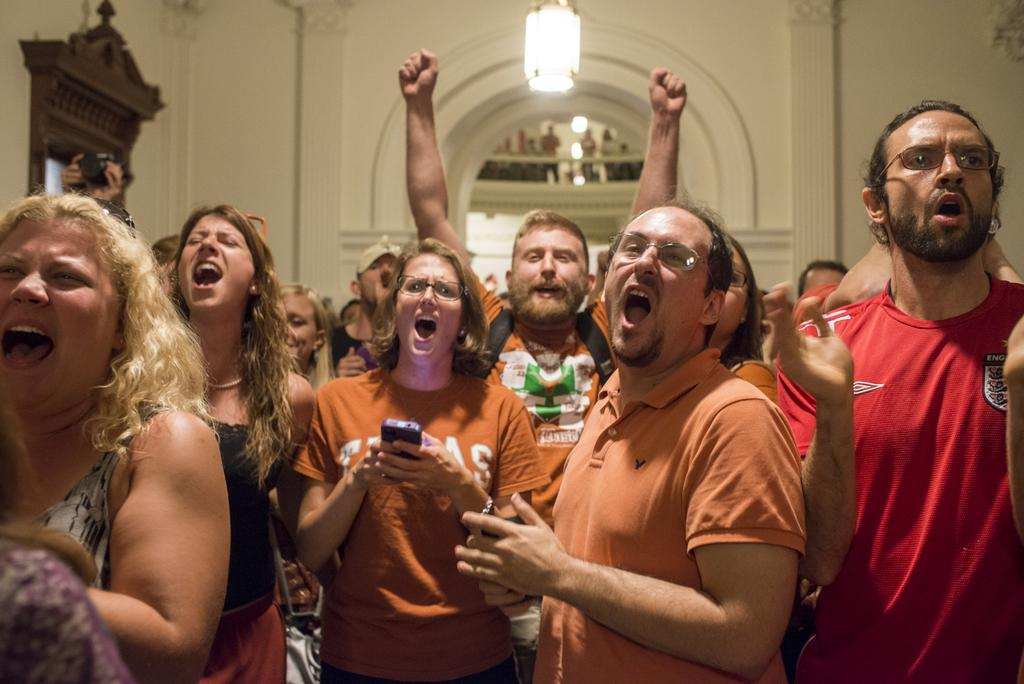What are the people in the image doing? The people in the image are standing and shouting. What can be seen in the background of the image? There is a wall in the background of the image. How can people enter or exit the area behind the wall? There is an entrance for the wall. What is present at the top of the wall? There is a light at the top of the wall. How much does the dime cost in the image? There is no dime present in the image, so it is not possible to determine its cost. 